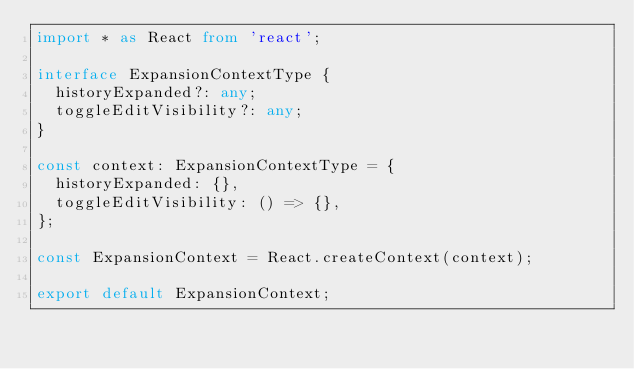<code> <loc_0><loc_0><loc_500><loc_500><_TypeScript_>import * as React from 'react';

interface ExpansionContextType {
  historyExpanded?: any;
  toggleEditVisibility?: any;
}

const context: ExpansionContextType = {
  historyExpanded: {},
  toggleEditVisibility: () => {},
};

const ExpansionContext = React.createContext(context);

export default ExpansionContext;
</code> 